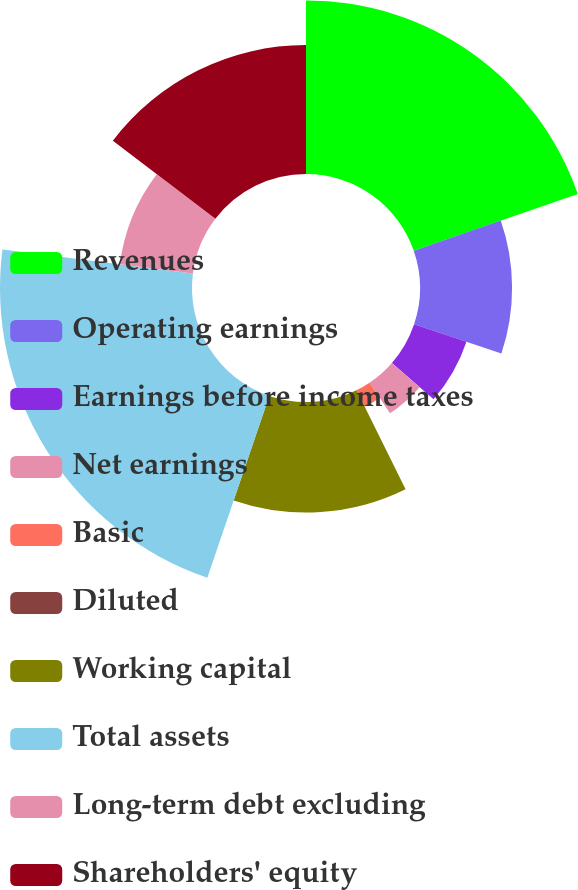Convert chart to OTSL. <chart><loc_0><loc_0><loc_500><loc_500><pie_chart><fcel>Revenues<fcel>Operating earnings<fcel>Earnings before income taxes<fcel>Net earnings<fcel>Basic<fcel>Diluted<fcel>Working capital<fcel>Total assets<fcel>Long-term debt excluding<fcel>Shareholders' equity<nl><fcel>19.7%<fcel>10.45%<fcel>6.27%<fcel>4.18%<fcel>2.09%<fcel>0.0%<fcel>12.54%<fcel>21.79%<fcel>8.36%<fcel>14.63%<nl></chart> 